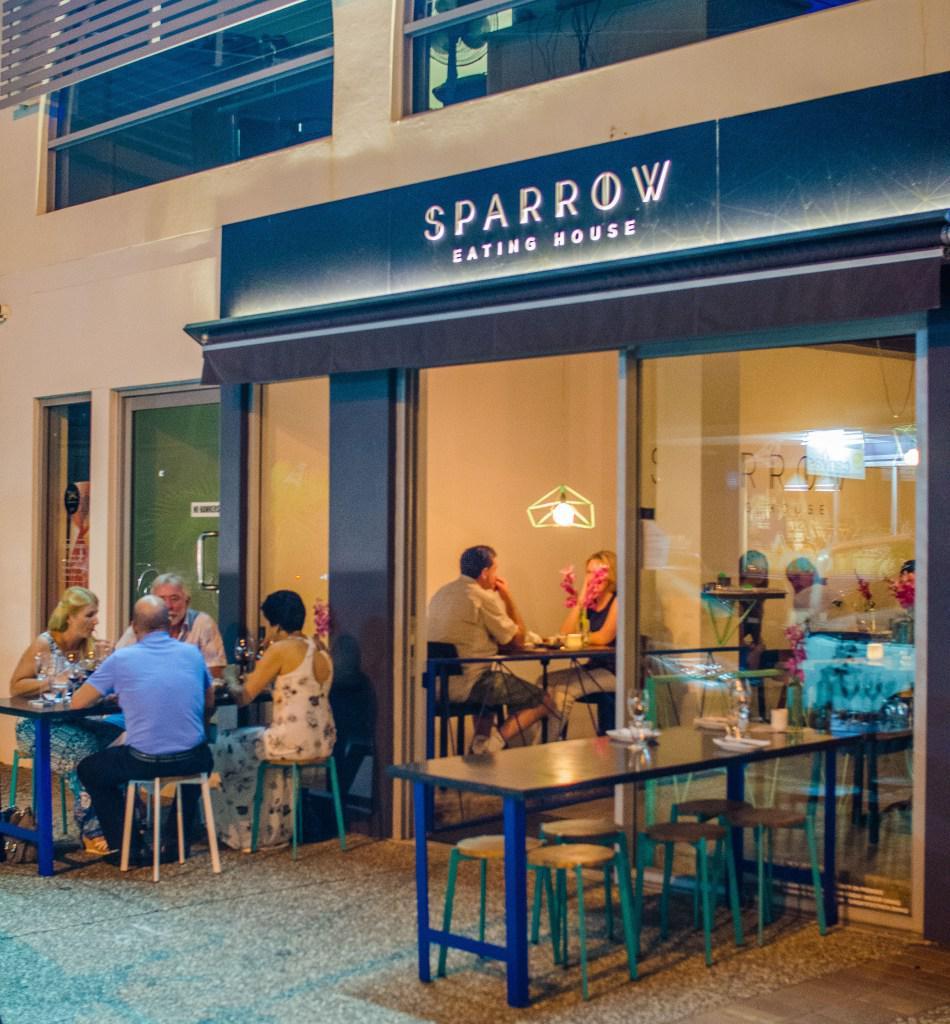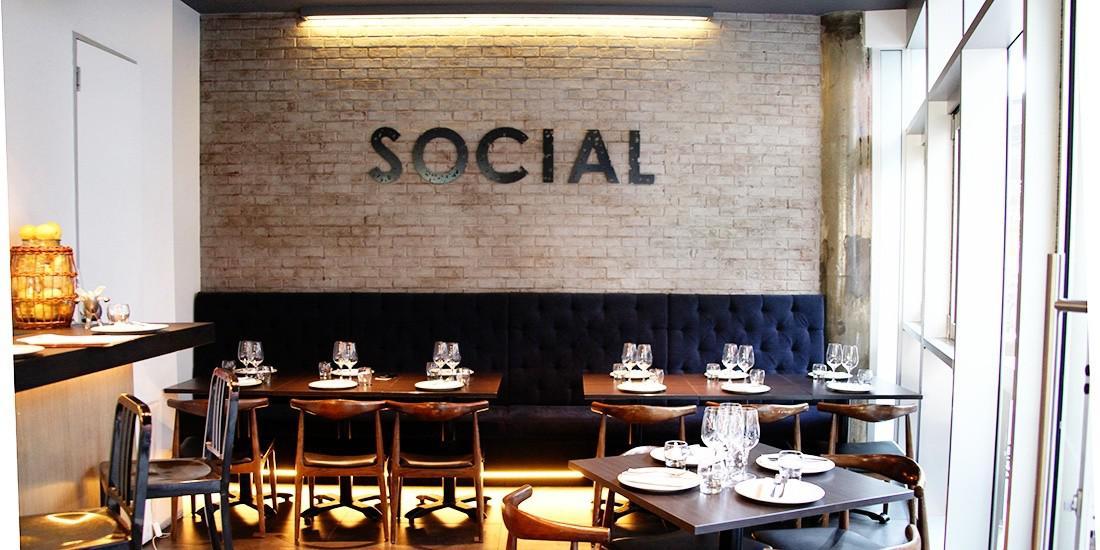The first image is the image on the left, the second image is the image on the right. Given the left and right images, does the statement "There are people dining in a restaurant with exposed lit bulbs haning from the ceiling" hold true? Answer yes or no. No. The first image is the image on the left, the second image is the image on the right. Given the left and right images, does the statement "The left image shows patrons dining at an establishment that features a curve of greenish columns, with a tree visible on the exterior." hold true? Answer yes or no. No. 